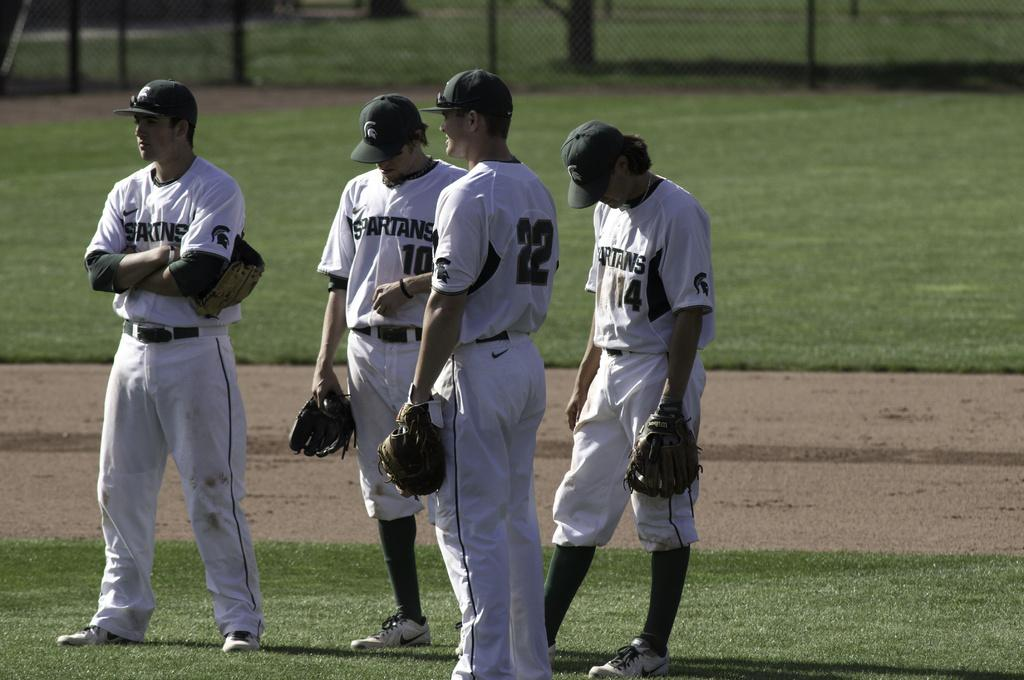<image>
Give a short and clear explanation of the subsequent image. Player number 10 for the Spartans looks down at the field 